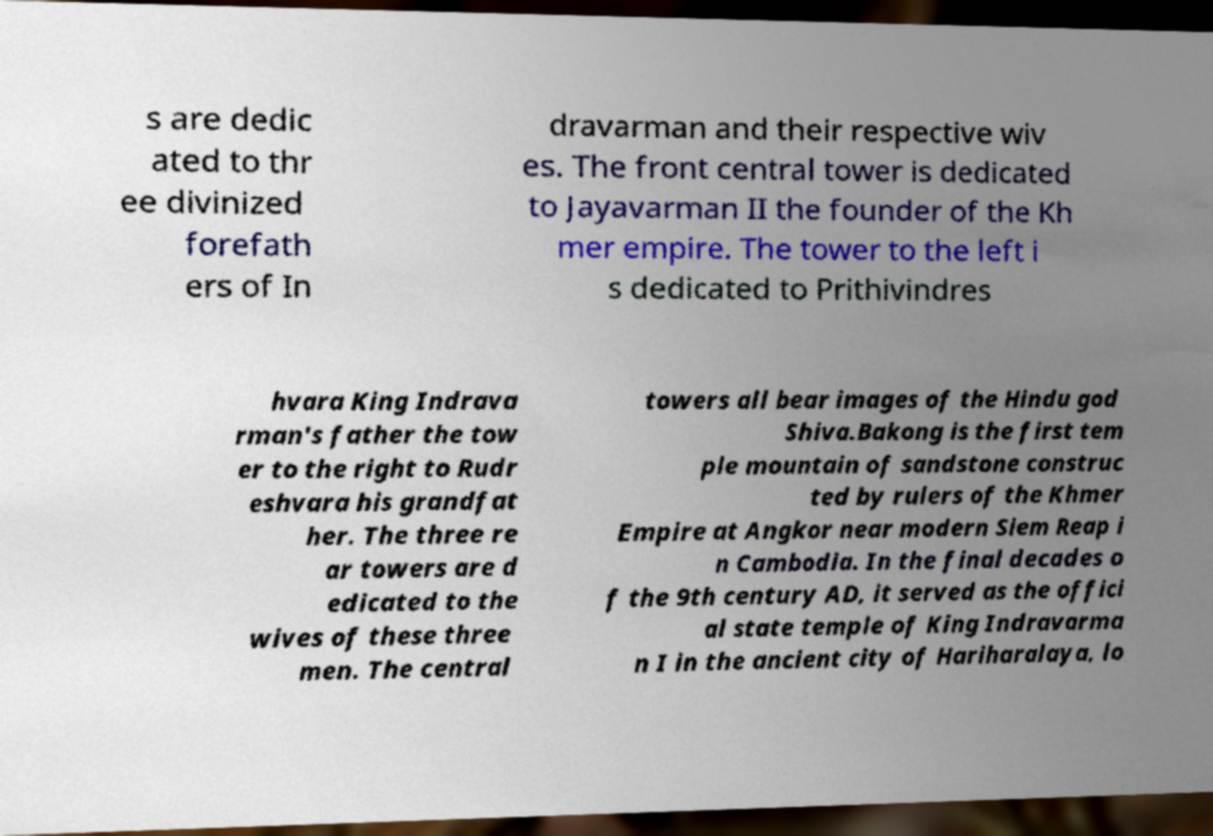Please identify and transcribe the text found in this image. s are dedic ated to thr ee divinized forefath ers of In dravarman and their respective wiv es. The front central tower is dedicated to Jayavarman II the founder of the Kh mer empire. The tower to the left i s dedicated to Prithivindres hvara King Indrava rman's father the tow er to the right to Rudr eshvara his grandfat her. The three re ar towers are d edicated to the wives of these three men. The central towers all bear images of the Hindu god Shiva.Bakong is the first tem ple mountain of sandstone construc ted by rulers of the Khmer Empire at Angkor near modern Siem Reap i n Cambodia. In the final decades o f the 9th century AD, it served as the offici al state temple of King Indravarma n I in the ancient city of Hariharalaya, lo 